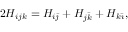Convert formula to latex. <formula><loc_0><loc_0><loc_500><loc_500>2 H _ { i j k } = H _ { i \bar { \jmath } } + H _ { j \bar { k } } + H _ { k \bar { \imath } } ,</formula> 